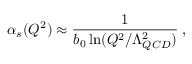Convert formula to latex. <formula><loc_0><loc_0><loc_500><loc_500>\alpha _ { s } ( Q ^ { 2 } ) \approx \frac { 1 } { b _ { 0 } \ln ( Q ^ { 2 } / \Lambda _ { Q C D } ^ { 2 } ) } \, ,</formula> 